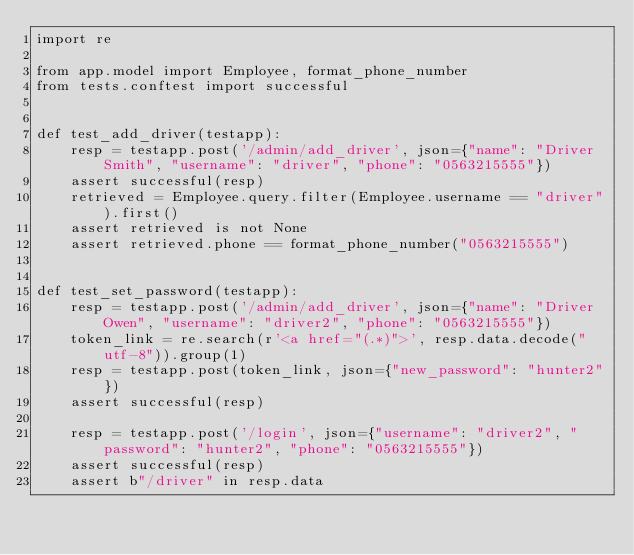Convert code to text. <code><loc_0><loc_0><loc_500><loc_500><_Python_>import re

from app.model import Employee, format_phone_number
from tests.conftest import successful


def test_add_driver(testapp):
    resp = testapp.post('/admin/add_driver', json={"name": "Driver Smith", "username": "driver", "phone": "0563215555"})
    assert successful(resp)
    retrieved = Employee.query.filter(Employee.username == "driver").first()
    assert retrieved is not None
    assert retrieved.phone == format_phone_number("0563215555")


def test_set_password(testapp):
    resp = testapp.post('/admin/add_driver', json={"name": "Driver Owen", "username": "driver2", "phone": "0563215555"})
    token_link = re.search(r'<a href="(.*)">', resp.data.decode("utf-8")).group(1)
    resp = testapp.post(token_link, json={"new_password": "hunter2"})
    assert successful(resp)

    resp = testapp.post('/login', json={"username": "driver2", "password": "hunter2", "phone": "0563215555"})
    assert successful(resp)
    assert b"/driver" in resp.data
</code> 